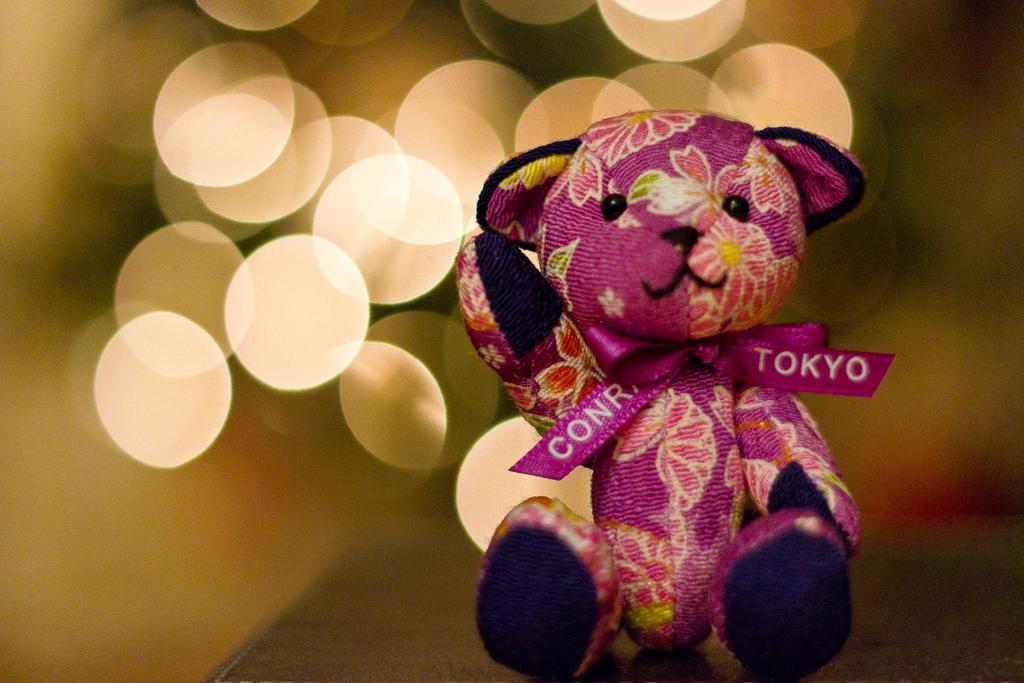How would you summarize this image in a sentence or two? In this image we can see a pink color toy with a pink color ribbon. The background is blurry. 